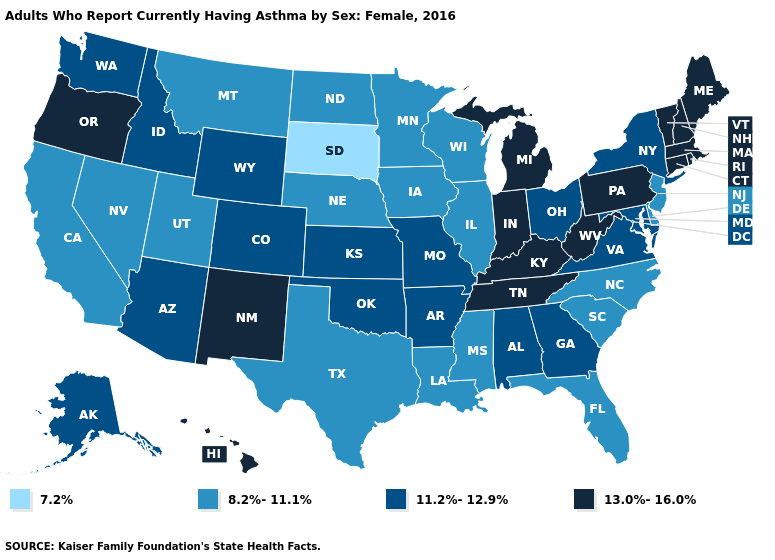How many symbols are there in the legend?
Keep it brief. 4. Does the map have missing data?
Be succinct. No. What is the value of Arizona?
Short answer required. 11.2%-12.9%. Which states have the lowest value in the USA?
Give a very brief answer. South Dakota. What is the highest value in the South ?
Keep it brief. 13.0%-16.0%. Does Missouri have a higher value than Connecticut?
Concise answer only. No. What is the value of Louisiana?
Concise answer only. 8.2%-11.1%. Does South Dakota have the lowest value in the USA?
Short answer required. Yes. Name the states that have a value in the range 13.0%-16.0%?
Give a very brief answer. Connecticut, Hawaii, Indiana, Kentucky, Maine, Massachusetts, Michigan, New Hampshire, New Mexico, Oregon, Pennsylvania, Rhode Island, Tennessee, Vermont, West Virginia. Does New Jersey have the highest value in the Northeast?
Give a very brief answer. No. Name the states that have a value in the range 11.2%-12.9%?
Quick response, please. Alabama, Alaska, Arizona, Arkansas, Colorado, Georgia, Idaho, Kansas, Maryland, Missouri, New York, Ohio, Oklahoma, Virginia, Washington, Wyoming. Does Texas have a lower value than South Carolina?
Be succinct. No. What is the value of Montana?
Keep it brief. 8.2%-11.1%. Which states hav the highest value in the West?
Be succinct. Hawaii, New Mexico, Oregon. What is the value of North Dakota?
Be succinct. 8.2%-11.1%. 